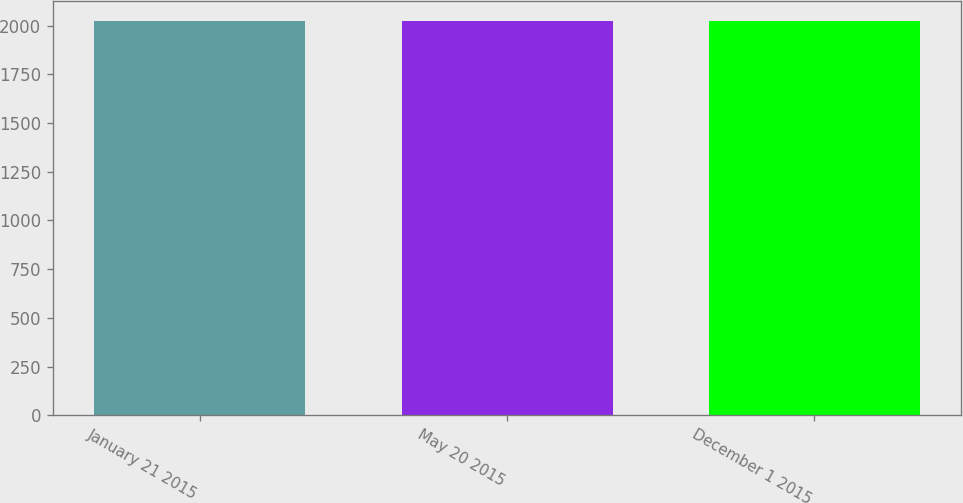<chart> <loc_0><loc_0><loc_500><loc_500><bar_chart><fcel>January 21 2015<fcel>May 20 2015<fcel>December 1 2015<nl><fcel>2025<fcel>2025.3<fcel>2022<nl></chart> 